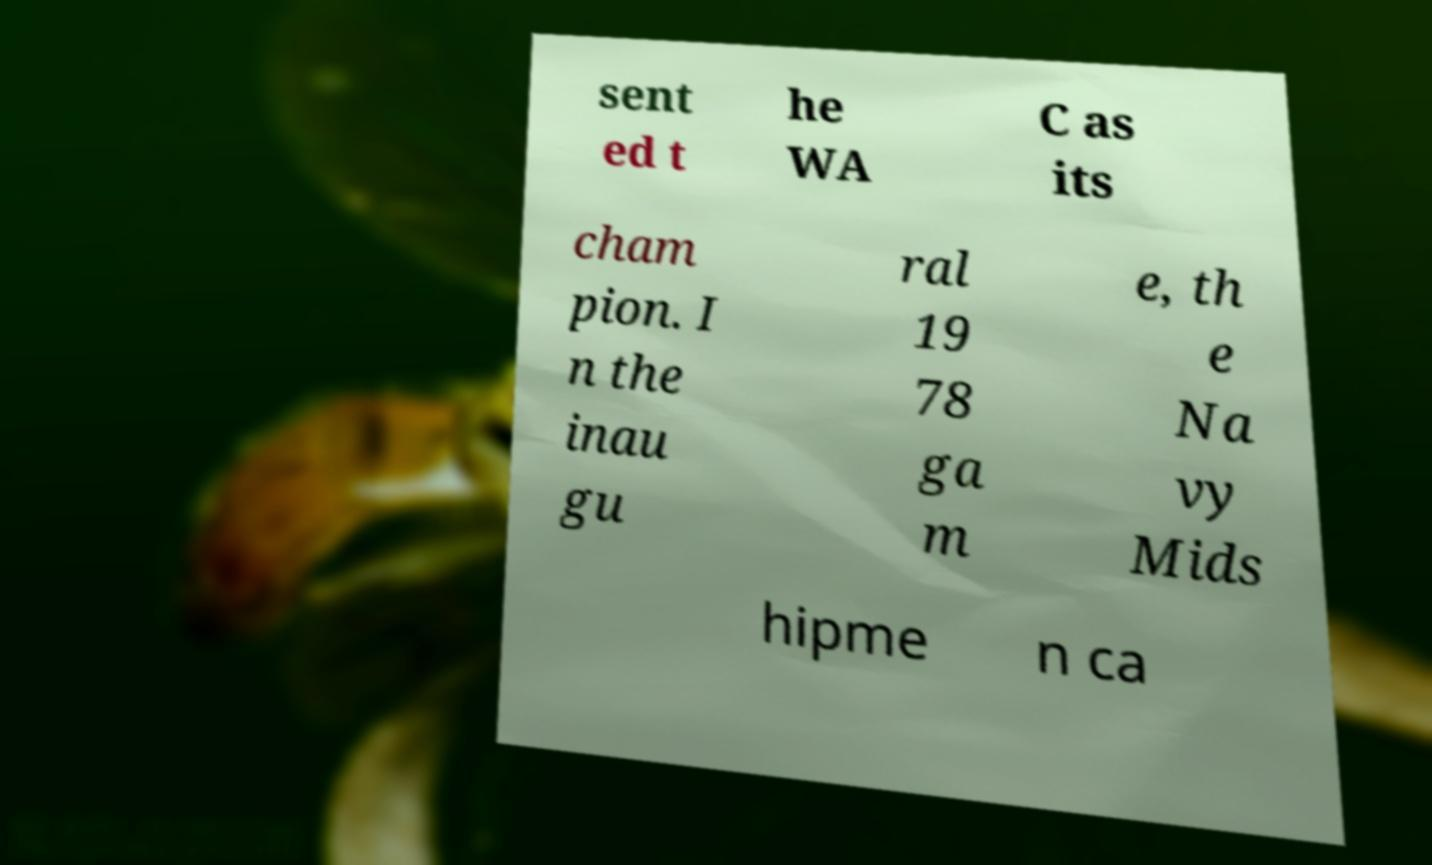I need the written content from this picture converted into text. Can you do that? sent ed t he WA C as its cham pion. I n the inau gu ral 19 78 ga m e, th e Na vy Mids hipme n ca 